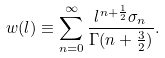Convert formula to latex. <formula><loc_0><loc_0><loc_500><loc_500>w ( l ) \equiv \sum _ { n = 0 } ^ { \infty } \frac { l ^ { n + \frac { 1 } { 2 } } \sigma _ { n } } { \Gamma ( n + \frac { 3 } { 2 } ) } .</formula> 